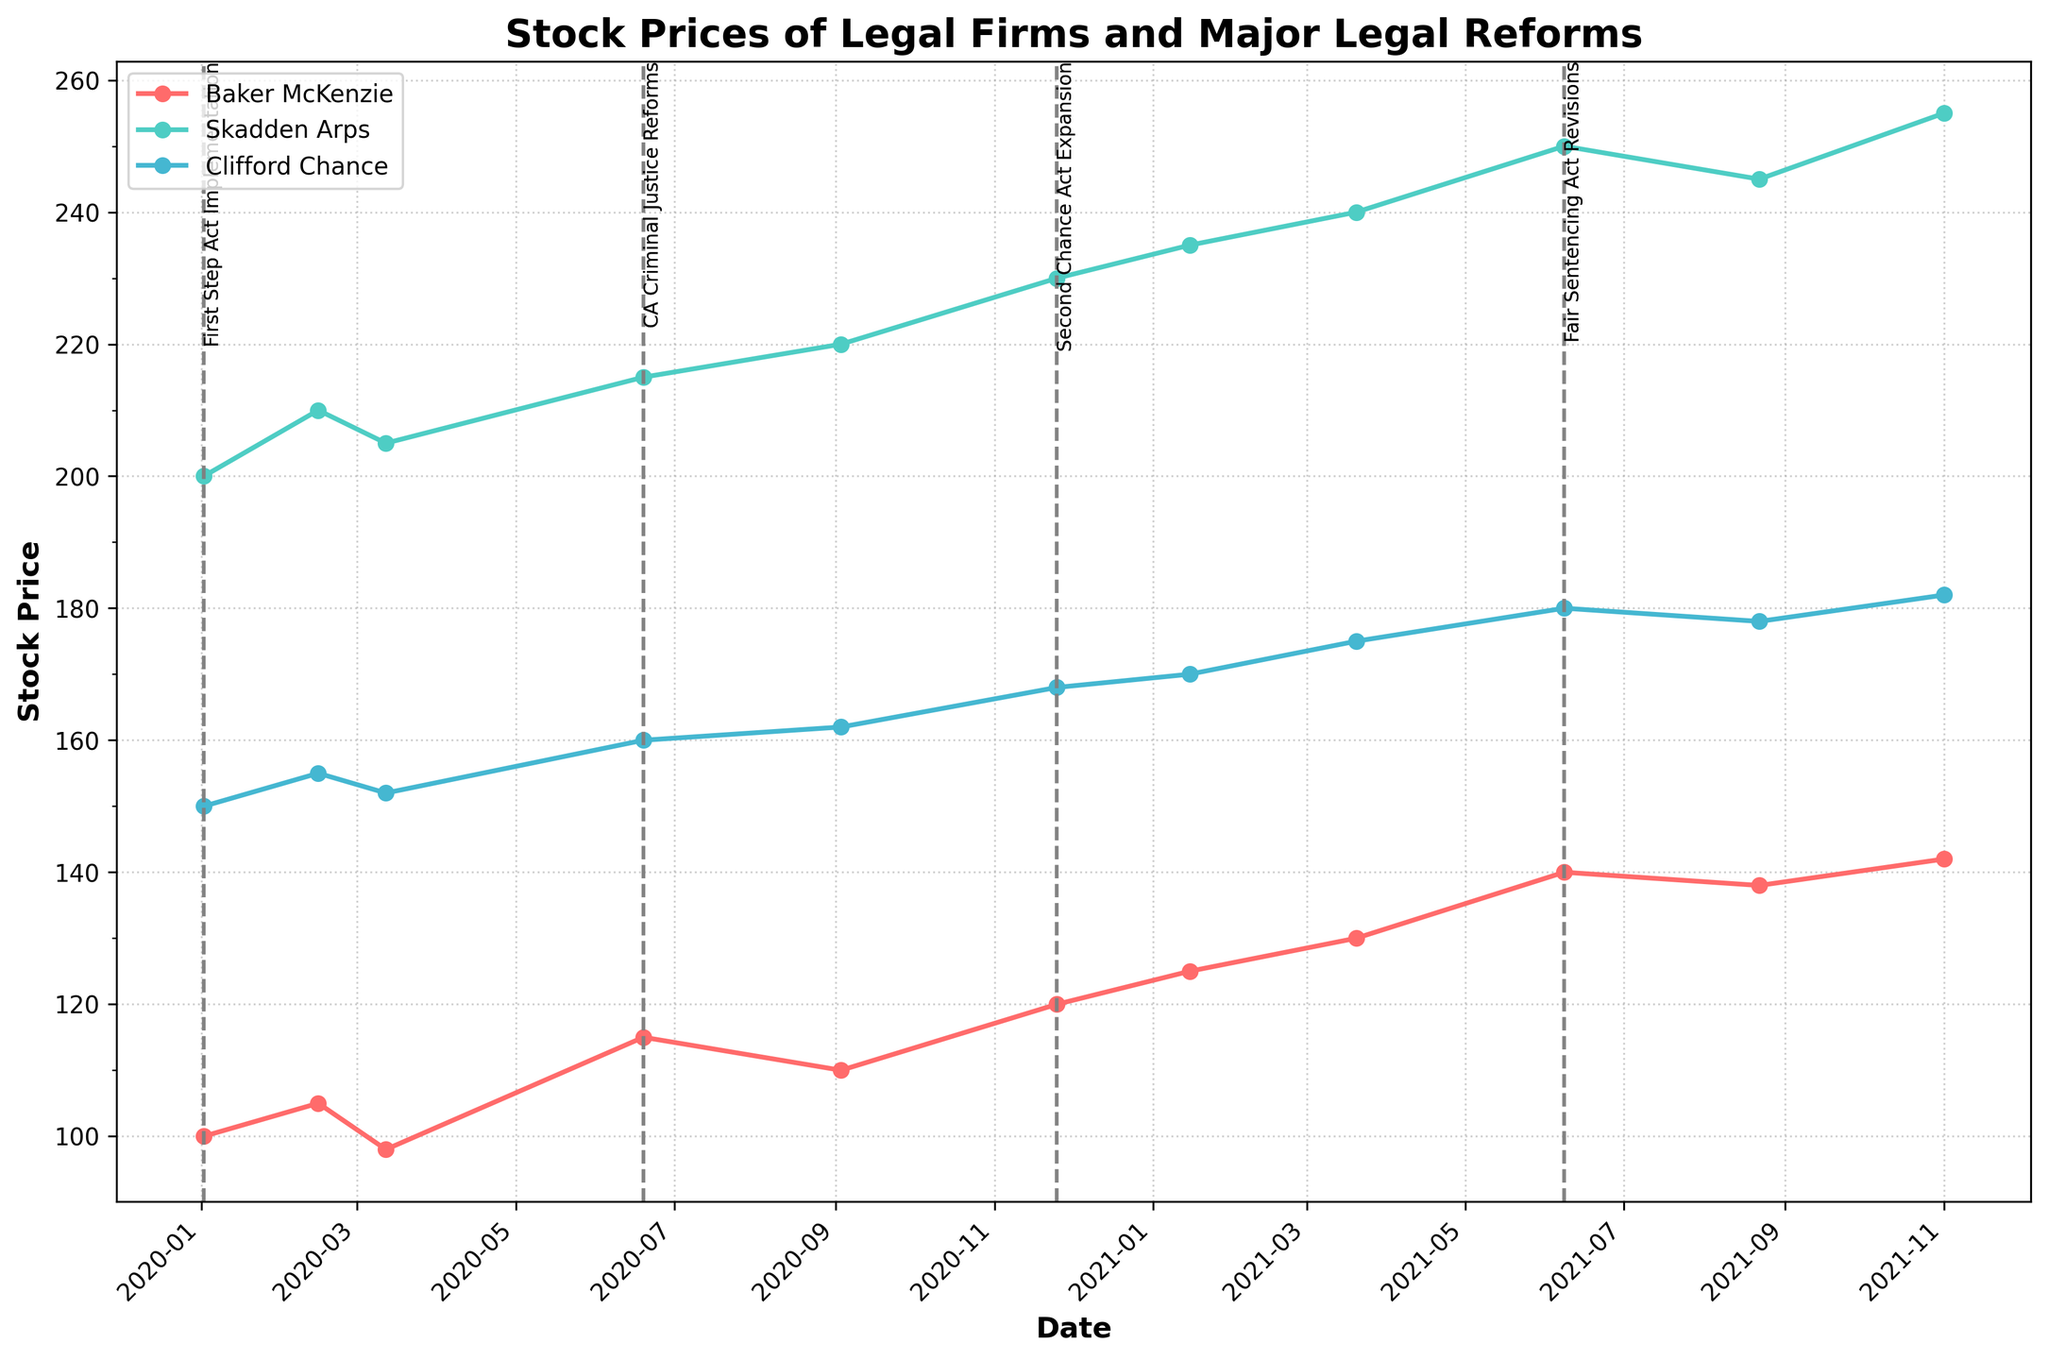What is the title of the figure? The title of the figure is located at the top of the plot. It provides a summary of what the plot represents.
Answer: Stock Prices of Legal Firms and Major Legal Reforms Which company's stock price has the highest value? To find the highest value, look at all the plotted lines and identify the peak value. The tallest point on the plot corresponds to Skadden Arps.
Answer: Skadden Arps During which reform did Baker McKenzie's stock price reach its highest value? Identify the peaks in Baker McKenzie's stock price line and cross-reference with the labeled vertical lines representing the reforms.
Answer: Fair Sentencing Act Revisions How does Clifford Chance's stock price generally trend over the period shown? Examine the line corresponding to Clifford Chance and observe the general direction from start to end.
Answer: Upward What is the difference in stock price for Skadden Arps between the Second Chance Act Expansion and Fair Sentencing Act Revisions? Find the values of Skadden Arps' stock price at the dates of these two reforms and calculate the difference: 250 - 230.
Answer: 20 How many reforms are indicated in the plot? Count the number of vertical dashed lines annotated with reform titles.
Answer: 4 Which company showed the most significant increase in stock price after the First Step Act Implementation? Compare the initial and subsequent values of each company's stock price following the date of this reform and identify the one with the largest increase.
Answer: Skadden Arps What was Baker McKenzie's stock price on 2021-03-20? Locate the date 2021-03-20 on the x-axis and look for the corresponding value for Baker McKenzie.
Answer: 130 During which reform did all companies experience a stock price increase? Identify the dates of the reforms and check if all the plotted lines (companies) ascend around the same period.
Answer: Second Chance Act Expansion Which company has the most volatile stock price? Look for the company whose stock price line shows the most fluctuations (up and down movements) over the period.
Answer: Baker McKenzie 